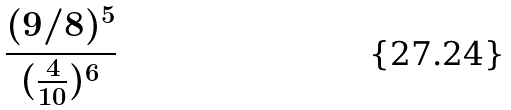Convert formula to latex. <formula><loc_0><loc_0><loc_500><loc_500>\frac { ( 9 / 8 ) ^ { 5 } } { ( \frac { 4 } { 1 0 } ) ^ { 6 } }</formula> 